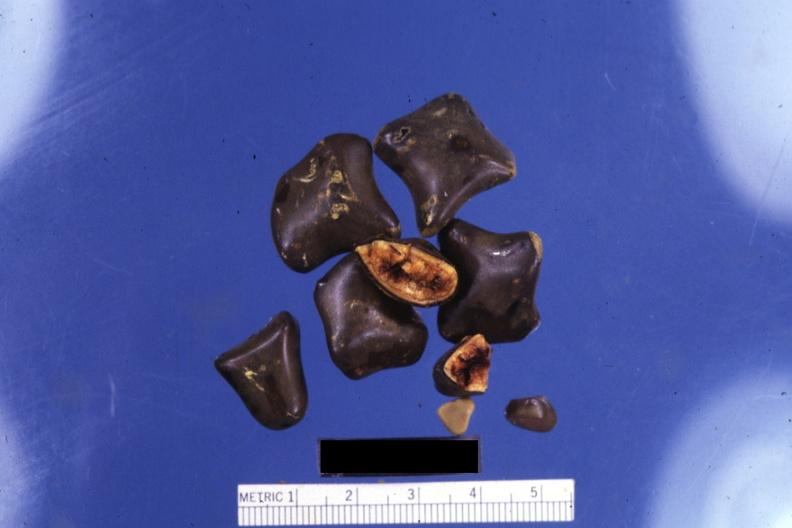s hepatobiliary present?
Answer the question using a single word or phrase. Yes 